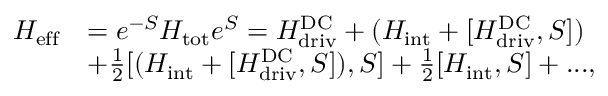Convert formula to latex. <formula><loc_0><loc_0><loc_500><loc_500>\begin{array} { r l } { H _ { e f f } } & { = { e ^ { - S } } H _ { t o t } { e ^ { S } } = H _ { d r i v } ^ { D C } + ( H _ { i n t } + [ H _ { d r i v } ^ { D C } , S ] ) } \\ & { + \frac { 1 } { 2 } [ ( H _ { i n t } + [ H _ { d r i v } ^ { D C } , S ] ) , S ] + \frac { 1 } { 2 } [ H _ { i n t } , S ] + \dots , } \end{array}</formula> 